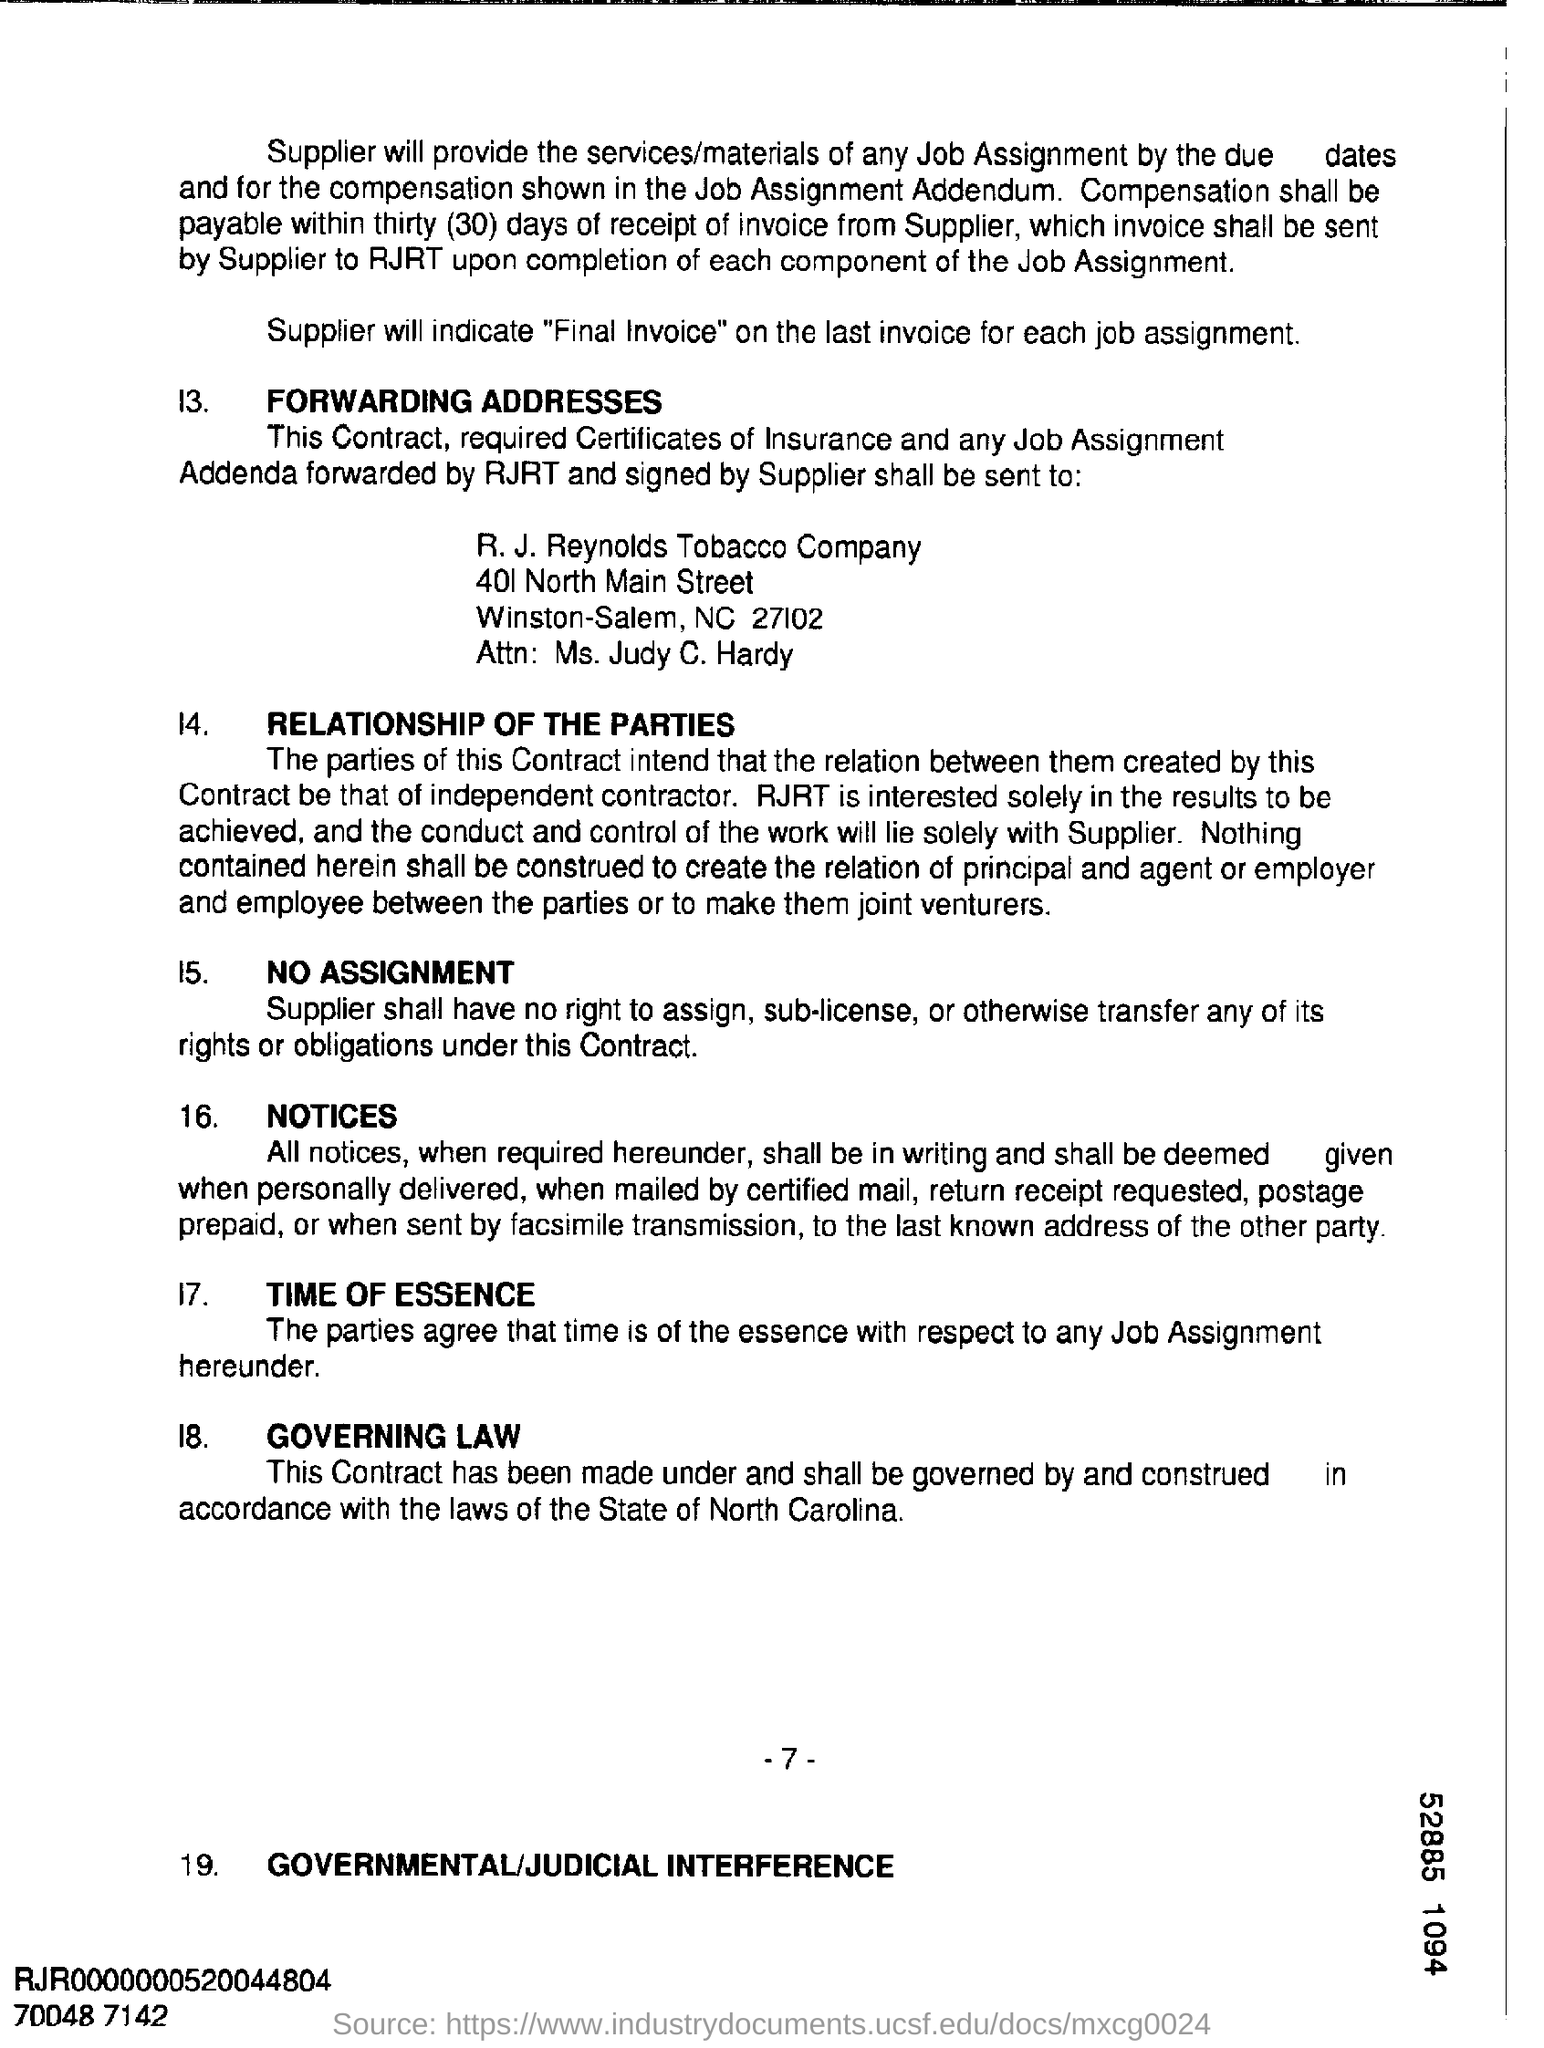What is number at the bottom right corner?
Your response must be concise. 52885 1094. 